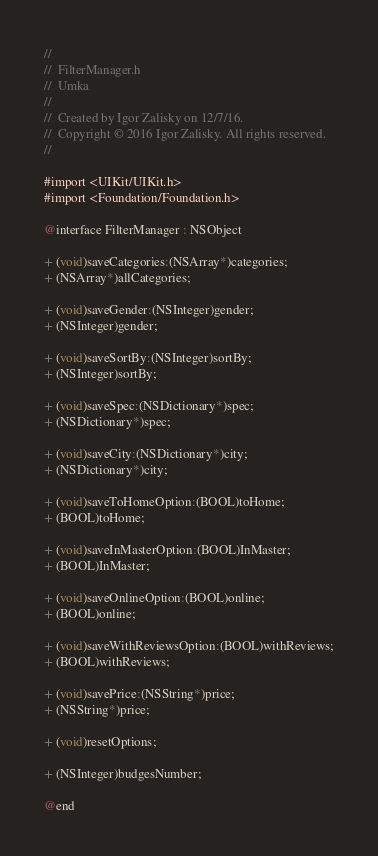<code> <loc_0><loc_0><loc_500><loc_500><_C_>//
//  FilterManager.h
//  Umka
//
//  Created by Igor Zalisky on 12/7/16.
//  Copyright © 2016 Igor Zalisky. All rights reserved.
//

#import <UIKit/UIKit.h>
#import <Foundation/Foundation.h>

@interface FilterManager : NSObject

+ (void)saveCategories:(NSArray*)categories;
+ (NSArray*)allCategories;

+ (void)saveGender:(NSInteger)gender;
+ (NSInteger)gender;

+ (void)saveSortBy:(NSInteger)sortBy;
+ (NSInteger)sortBy;

+ (void)saveSpec:(NSDictionary*)spec;
+ (NSDictionary*)spec;

+ (void)saveCity:(NSDictionary*)city;
+ (NSDictionary*)city;

+ (void)saveToHomeOption:(BOOL)toHome;
+ (BOOL)toHome;

+ (void)saveInMasterOption:(BOOL)InMaster;
+ (BOOL)InMaster;

+ (void)saveOnlineOption:(BOOL)online;
+ (BOOL)online;

+ (void)saveWithReviewsOption:(BOOL)withReviews;
+ (BOOL)withReviews;

+ (void)savePrice:(NSString*)price;
+ (NSString*)price;

+ (void)resetOptions;

+ (NSInteger)budgesNumber;

@end
</code> 